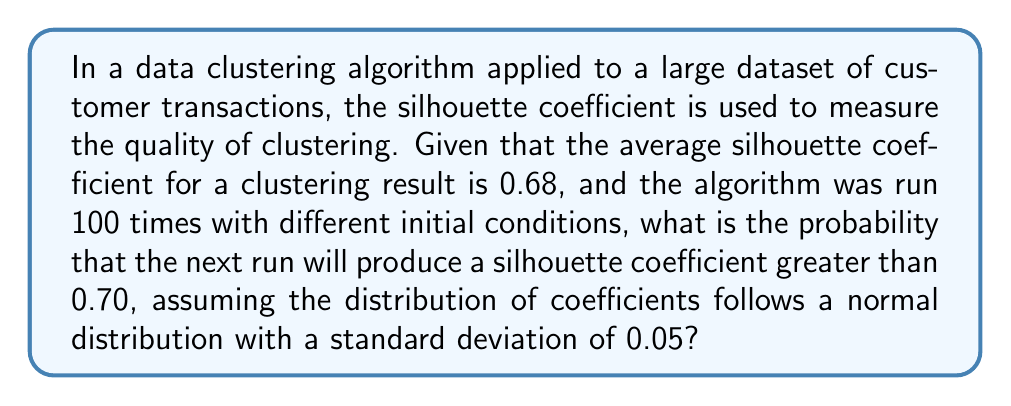Can you solve this math problem? To solve this problem, we'll follow these steps:

1) First, we need to recognize that we're dealing with a normal distribution with the following parameters:
   Mean (μ) = 0.68
   Standard deviation (σ) = 0.05

2) We want to find the probability of getting a value greater than 0.70. In statistical terms, we need to find P(X > 0.70), where X is our random variable.

3) To use the standard normal distribution table, we need to convert our value to a z-score:

   $$z = \frac{x - \mu}{\sigma} = \frac{0.70 - 0.68}{0.05} = 0.40$$

4) Now, we need to find P(Z > 0.40) in the standard normal distribution.

5) From a standard normal distribution table, we can find that P(Z < 0.40) ≈ 0.6554

6) Since we want P(Z > 0.40), and we know that the total probability is 1, we can calculate:

   P(Z > 0.40) = 1 - P(Z < 0.40) = 1 - 0.6554 = 0.3446

7) Therefore, the probability of getting a silhouette coefficient greater than 0.70 in the next run is approximately 0.3446 or 34.46%.

This approach is similar to analyzing query execution times in SQL, where you might look at the distribution of query durations to estimate the likelihood of a query exceeding a certain time threshold.
Answer: 0.3446 